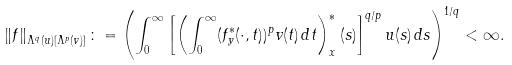Convert formula to latex. <formula><loc_0><loc_0><loc_500><loc_500>\left \| f \right \| _ { \Lambda ^ { q } ( { u } ) [ \Lambda ^ { p } ( { v } ) ] } \colon = \left ( \int _ { 0 } ^ { \infty } \left [ \left ( \int _ { 0 } ^ { \infty } ( f _ { y } ^ { \ast } ( \cdot , t ) ) ^ { p } v ( t ) \, d t \right ) _ { x } ^ { \ast } ( s ) \right ] ^ { q / p } u ( s ) \, d s \right ) ^ { 1 / q } < \infty .</formula> 